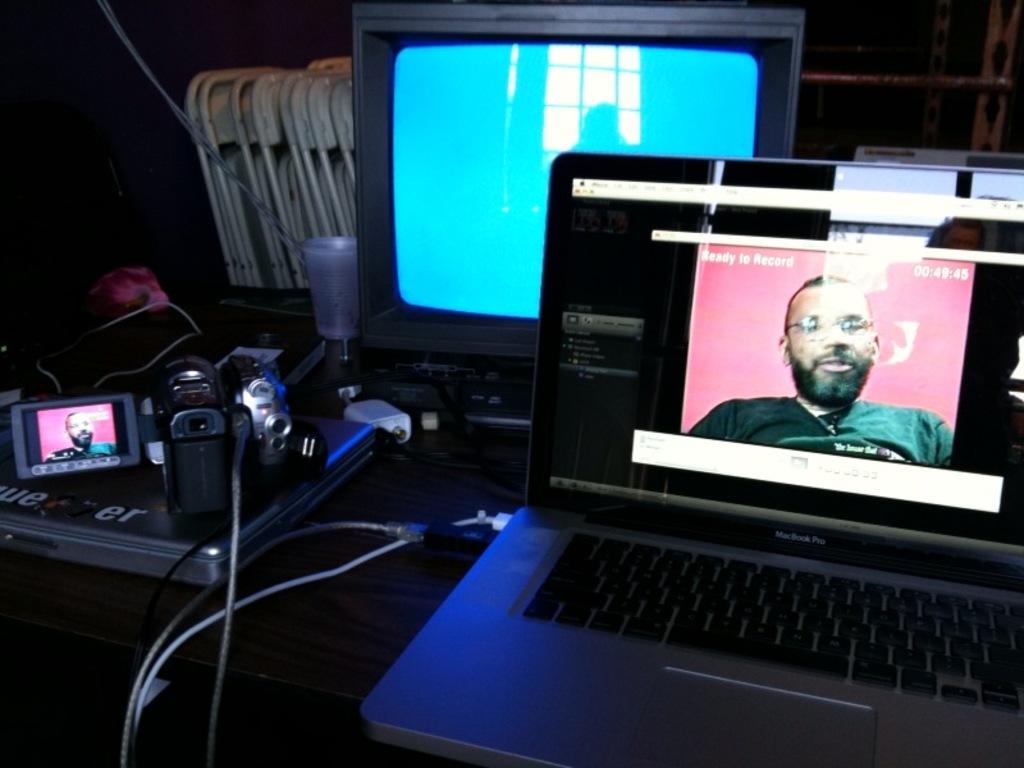Is this ready to record?
Give a very brief answer. Yes. What are the numbers in the top right corner of the computer screen?
Keep it short and to the point. 00:49:45. 